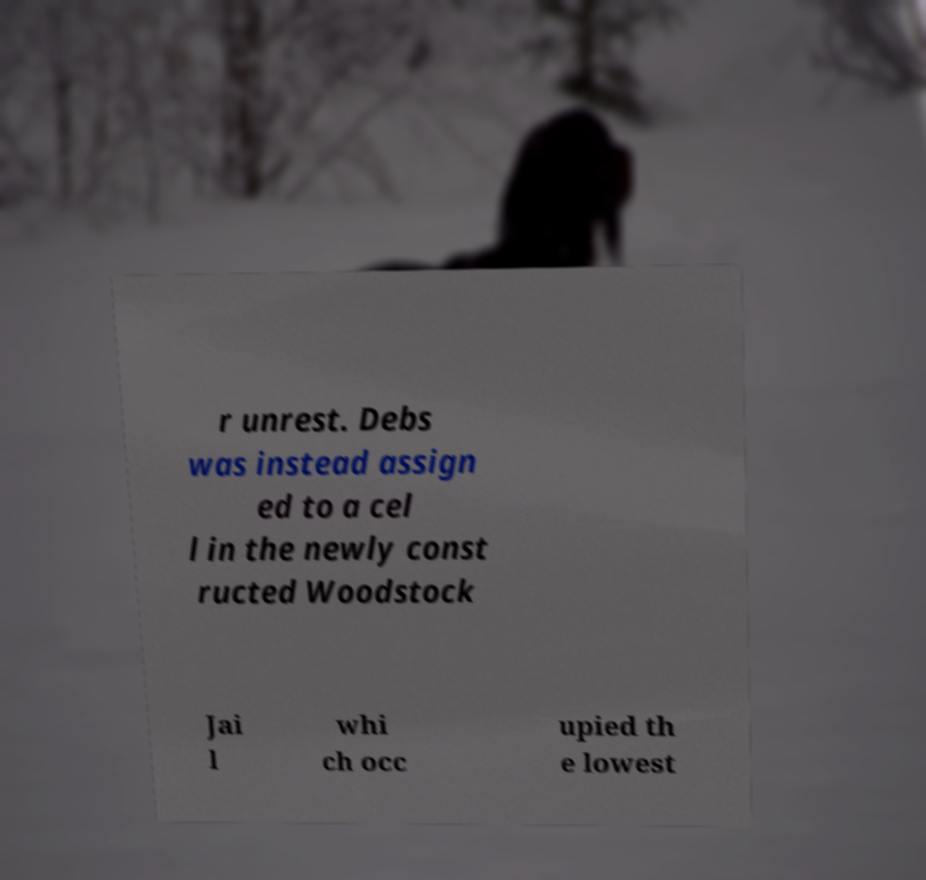There's text embedded in this image that I need extracted. Can you transcribe it verbatim? r unrest. Debs was instead assign ed to a cel l in the newly const ructed Woodstock Jai l whi ch occ upied th e lowest 